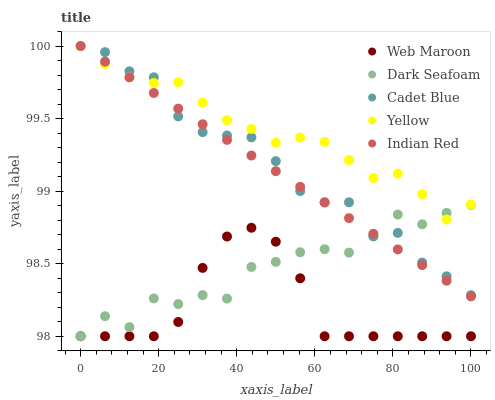Does Web Maroon have the minimum area under the curve?
Answer yes or no. Yes. Does Yellow have the maximum area under the curve?
Answer yes or no. Yes. Does Cadet Blue have the minimum area under the curve?
Answer yes or no. No. Does Cadet Blue have the maximum area under the curve?
Answer yes or no. No. Is Indian Red the smoothest?
Answer yes or no. Yes. Is Dark Seafoam the roughest?
Answer yes or no. Yes. Is Cadet Blue the smoothest?
Answer yes or no. No. Is Cadet Blue the roughest?
Answer yes or no. No. Does Dark Seafoam have the lowest value?
Answer yes or no. Yes. Does Cadet Blue have the lowest value?
Answer yes or no. No. Does Yellow have the highest value?
Answer yes or no. Yes. Does Web Maroon have the highest value?
Answer yes or no. No. Is Web Maroon less than Yellow?
Answer yes or no. Yes. Is Indian Red greater than Web Maroon?
Answer yes or no. Yes. Does Cadet Blue intersect Yellow?
Answer yes or no. Yes. Is Cadet Blue less than Yellow?
Answer yes or no. No. Is Cadet Blue greater than Yellow?
Answer yes or no. No. Does Web Maroon intersect Yellow?
Answer yes or no. No. 